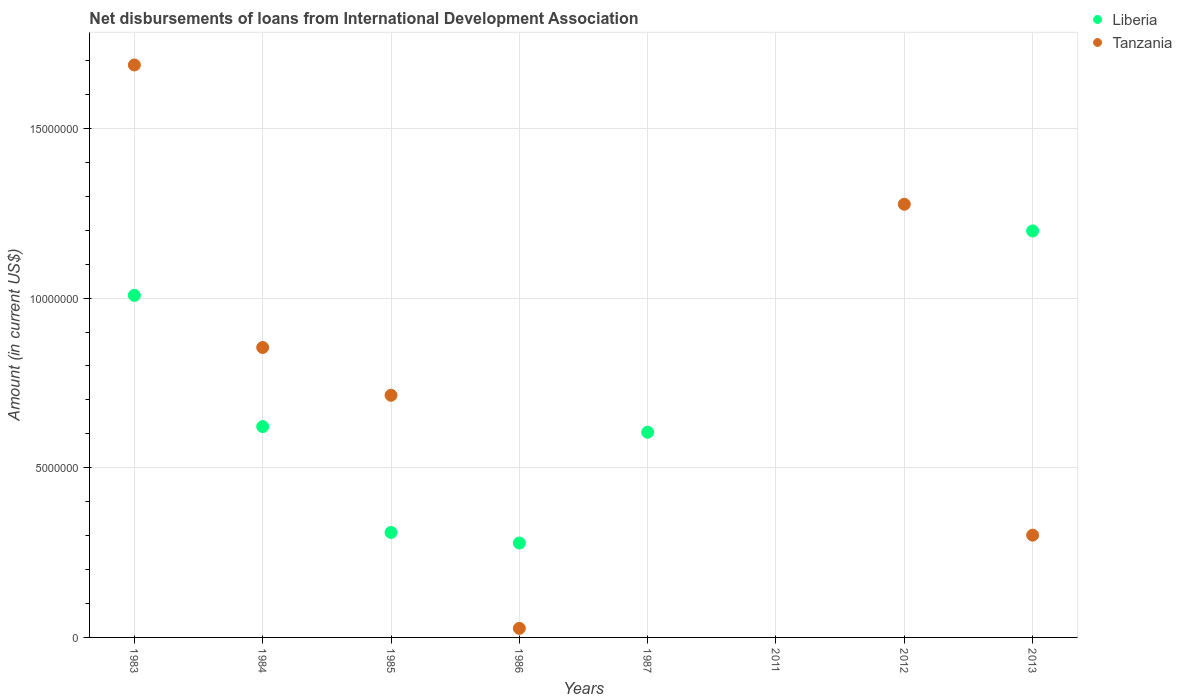How many different coloured dotlines are there?
Offer a very short reply. 2. Is the number of dotlines equal to the number of legend labels?
Make the answer very short. No. What is the amount of loans disbursed in Liberia in 1986?
Provide a succinct answer. 2.78e+06. Across all years, what is the maximum amount of loans disbursed in Liberia?
Provide a short and direct response. 1.20e+07. In which year was the amount of loans disbursed in Liberia maximum?
Make the answer very short. 2013. What is the total amount of loans disbursed in Tanzania in the graph?
Your answer should be compact. 4.86e+07. What is the difference between the amount of loans disbursed in Liberia in 1983 and that in 2013?
Provide a succinct answer. -1.90e+06. What is the difference between the amount of loans disbursed in Tanzania in 1984 and the amount of loans disbursed in Liberia in 2013?
Provide a short and direct response. -3.44e+06. What is the average amount of loans disbursed in Liberia per year?
Keep it short and to the point. 5.02e+06. In the year 1986, what is the difference between the amount of loans disbursed in Tanzania and amount of loans disbursed in Liberia?
Provide a short and direct response. -2.52e+06. What is the ratio of the amount of loans disbursed in Liberia in 1983 to that in 2013?
Provide a short and direct response. 0.84. Is the difference between the amount of loans disbursed in Tanzania in 1984 and 1986 greater than the difference between the amount of loans disbursed in Liberia in 1984 and 1986?
Offer a very short reply. Yes. What is the difference between the highest and the second highest amount of loans disbursed in Tanzania?
Provide a succinct answer. 4.10e+06. What is the difference between the highest and the lowest amount of loans disbursed in Tanzania?
Provide a short and direct response. 1.69e+07. In how many years, is the amount of loans disbursed in Liberia greater than the average amount of loans disbursed in Liberia taken over all years?
Provide a short and direct response. 4. Is the sum of the amount of loans disbursed in Tanzania in 1984 and 2013 greater than the maximum amount of loans disbursed in Liberia across all years?
Give a very brief answer. No. Does the amount of loans disbursed in Tanzania monotonically increase over the years?
Offer a very short reply. No. Is the amount of loans disbursed in Liberia strictly greater than the amount of loans disbursed in Tanzania over the years?
Give a very brief answer. No. How many dotlines are there?
Your answer should be very brief. 2. What is the difference between two consecutive major ticks on the Y-axis?
Ensure brevity in your answer.  5.00e+06. Are the values on the major ticks of Y-axis written in scientific E-notation?
Keep it short and to the point. No. Does the graph contain grids?
Give a very brief answer. Yes. Where does the legend appear in the graph?
Your answer should be very brief. Top right. How many legend labels are there?
Give a very brief answer. 2. What is the title of the graph?
Your response must be concise. Net disbursements of loans from International Development Association. Does "Malaysia" appear as one of the legend labels in the graph?
Keep it short and to the point. No. What is the label or title of the X-axis?
Give a very brief answer. Years. What is the Amount (in current US$) in Liberia in 1983?
Make the answer very short. 1.01e+07. What is the Amount (in current US$) in Tanzania in 1983?
Provide a short and direct response. 1.69e+07. What is the Amount (in current US$) in Liberia in 1984?
Offer a terse response. 6.21e+06. What is the Amount (in current US$) in Tanzania in 1984?
Ensure brevity in your answer.  8.54e+06. What is the Amount (in current US$) of Liberia in 1985?
Give a very brief answer. 3.09e+06. What is the Amount (in current US$) in Tanzania in 1985?
Give a very brief answer. 7.14e+06. What is the Amount (in current US$) of Liberia in 1986?
Provide a short and direct response. 2.78e+06. What is the Amount (in current US$) in Tanzania in 1986?
Provide a succinct answer. 2.67e+05. What is the Amount (in current US$) of Liberia in 1987?
Your answer should be compact. 6.05e+06. What is the Amount (in current US$) in Tanzania in 2011?
Provide a succinct answer. 0. What is the Amount (in current US$) of Liberia in 2012?
Your answer should be very brief. 0. What is the Amount (in current US$) in Tanzania in 2012?
Your answer should be very brief. 1.28e+07. What is the Amount (in current US$) in Liberia in 2013?
Offer a terse response. 1.20e+07. What is the Amount (in current US$) of Tanzania in 2013?
Provide a short and direct response. 3.01e+06. Across all years, what is the maximum Amount (in current US$) in Liberia?
Provide a succinct answer. 1.20e+07. Across all years, what is the maximum Amount (in current US$) of Tanzania?
Your answer should be very brief. 1.69e+07. Across all years, what is the minimum Amount (in current US$) of Tanzania?
Offer a terse response. 0. What is the total Amount (in current US$) of Liberia in the graph?
Offer a terse response. 4.02e+07. What is the total Amount (in current US$) in Tanzania in the graph?
Your answer should be very brief. 4.86e+07. What is the difference between the Amount (in current US$) of Liberia in 1983 and that in 1984?
Your answer should be compact. 3.87e+06. What is the difference between the Amount (in current US$) of Tanzania in 1983 and that in 1984?
Ensure brevity in your answer.  8.32e+06. What is the difference between the Amount (in current US$) of Liberia in 1983 and that in 1985?
Your response must be concise. 6.99e+06. What is the difference between the Amount (in current US$) in Tanzania in 1983 and that in 1985?
Offer a very short reply. 9.73e+06. What is the difference between the Amount (in current US$) in Liberia in 1983 and that in 1986?
Your answer should be compact. 7.30e+06. What is the difference between the Amount (in current US$) in Tanzania in 1983 and that in 1986?
Offer a very short reply. 1.66e+07. What is the difference between the Amount (in current US$) of Liberia in 1983 and that in 1987?
Offer a terse response. 4.03e+06. What is the difference between the Amount (in current US$) of Tanzania in 1983 and that in 2012?
Your answer should be compact. 4.10e+06. What is the difference between the Amount (in current US$) of Liberia in 1983 and that in 2013?
Provide a succinct answer. -1.90e+06. What is the difference between the Amount (in current US$) of Tanzania in 1983 and that in 2013?
Offer a very short reply. 1.39e+07. What is the difference between the Amount (in current US$) in Liberia in 1984 and that in 1985?
Provide a succinct answer. 3.12e+06. What is the difference between the Amount (in current US$) in Tanzania in 1984 and that in 1985?
Offer a terse response. 1.41e+06. What is the difference between the Amount (in current US$) in Liberia in 1984 and that in 1986?
Your answer should be compact. 3.43e+06. What is the difference between the Amount (in current US$) in Tanzania in 1984 and that in 1986?
Offer a terse response. 8.28e+06. What is the difference between the Amount (in current US$) in Liberia in 1984 and that in 1987?
Make the answer very short. 1.66e+05. What is the difference between the Amount (in current US$) in Tanzania in 1984 and that in 2012?
Your response must be concise. -4.22e+06. What is the difference between the Amount (in current US$) of Liberia in 1984 and that in 2013?
Ensure brevity in your answer.  -5.77e+06. What is the difference between the Amount (in current US$) in Tanzania in 1984 and that in 2013?
Your response must be concise. 5.53e+06. What is the difference between the Amount (in current US$) in Liberia in 1985 and that in 1986?
Offer a very short reply. 3.11e+05. What is the difference between the Amount (in current US$) in Tanzania in 1985 and that in 1986?
Give a very brief answer. 6.87e+06. What is the difference between the Amount (in current US$) of Liberia in 1985 and that in 1987?
Provide a short and direct response. -2.95e+06. What is the difference between the Amount (in current US$) of Tanzania in 1985 and that in 2012?
Make the answer very short. -5.63e+06. What is the difference between the Amount (in current US$) of Liberia in 1985 and that in 2013?
Your response must be concise. -8.89e+06. What is the difference between the Amount (in current US$) of Tanzania in 1985 and that in 2013?
Your answer should be compact. 4.12e+06. What is the difference between the Amount (in current US$) in Liberia in 1986 and that in 1987?
Provide a short and direct response. -3.26e+06. What is the difference between the Amount (in current US$) in Tanzania in 1986 and that in 2012?
Your answer should be very brief. -1.25e+07. What is the difference between the Amount (in current US$) of Liberia in 1986 and that in 2013?
Keep it short and to the point. -9.20e+06. What is the difference between the Amount (in current US$) of Tanzania in 1986 and that in 2013?
Keep it short and to the point. -2.75e+06. What is the difference between the Amount (in current US$) of Liberia in 1987 and that in 2013?
Provide a succinct answer. -5.93e+06. What is the difference between the Amount (in current US$) in Tanzania in 2012 and that in 2013?
Offer a very short reply. 9.75e+06. What is the difference between the Amount (in current US$) of Liberia in 1983 and the Amount (in current US$) of Tanzania in 1984?
Offer a terse response. 1.54e+06. What is the difference between the Amount (in current US$) of Liberia in 1983 and the Amount (in current US$) of Tanzania in 1985?
Provide a short and direct response. 2.94e+06. What is the difference between the Amount (in current US$) of Liberia in 1983 and the Amount (in current US$) of Tanzania in 1986?
Your answer should be compact. 9.81e+06. What is the difference between the Amount (in current US$) of Liberia in 1983 and the Amount (in current US$) of Tanzania in 2012?
Your response must be concise. -2.68e+06. What is the difference between the Amount (in current US$) in Liberia in 1983 and the Amount (in current US$) in Tanzania in 2013?
Offer a terse response. 7.07e+06. What is the difference between the Amount (in current US$) of Liberia in 1984 and the Amount (in current US$) of Tanzania in 1985?
Your response must be concise. -9.23e+05. What is the difference between the Amount (in current US$) in Liberia in 1984 and the Amount (in current US$) in Tanzania in 1986?
Give a very brief answer. 5.95e+06. What is the difference between the Amount (in current US$) of Liberia in 1984 and the Amount (in current US$) of Tanzania in 2012?
Your answer should be very brief. -6.55e+06. What is the difference between the Amount (in current US$) of Liberia in 1984 and the Amount (in current US$) of Tanzania in 2013?
Give a very brief answer. 3.20e+06. What is the difference between the Amount (in current US$) in Liberia in 1985 and the Amount (in current US$) in Tanzania in 1986?
Offer a very short reply. 2.83e+06. What is the difference between the Amount (in current US$) in Liberia in 1985 and the Amount (in current US$) in Tanzania in 2012?
Provide a succinct answer. -9.67e+06. What is the difference between the Amount (in current US$) of Liberia in 1985 and the Amount (in current US$) of Tanzania in 2013?
Give a very brief answer. 7.90e+04. What is the difference between the Amount (in current US$) of Liberia in 1986 and the Amount (in current US$) of Tanzania in 2012?
Ensure brevity in your answer.  -9.98e+06. What is the difference between the Amount (in current US$) in Liberia in 1986 and the Amount (in current US$) in Tanzania in 2013?
Your response must be concise. -2.32e+05. What is the difference between the Amount (in current US$) of Liberia in 1987 and the Amount (in current US$) of Tanzania in 2012?
Provide a short and direct response. -6.72e+06. What is the difference between the Amount (in current US$) of Liberia in 1987 and the Amount (in current US$) of Tanzania in 2013?
Provide a short and direct response. 3.03e+06. What is the average Amount (in current US$) in Liberia per year?
Make the answer very short. 5.02e+06. What is the average Amount (in current US$) of Tanzania per year?
Make the answer very short. 6.07e+06. In the year 1983, what is the difference between the Amount (in current US$) in Liberia and Amount (in current US$) in Tanzania?
Your answer should be very brief. -6.79e+06. In the year 1984, what is the difference between the Amount (in current US$) in Liberia and Amount (in current US$) in Tanzania?
Make the answer very short. -2.33e+06. In the year 1985, what is the difference between the Amount (in current US$) in Liberia and Amount (in current US$) in Tanzania?
Provide a succinct answer. -4.04e+06. In the year 1986, what is the difference between the Amount (in current US$) in Liberia and Amount (in current US$) in Tanzania?
Keep it short and to the point. 2.52e+06. In the year 2013, what is the difference between the Amount (in current US$) in Liberia and Amount (in current US$) in Tanzania?
Make the answer very short. 8.96e+06. What is the ratio of the Amount (in current US$) in Liberia in 1983 to that in 1984?
Provide a short and direct response. 1.62. What is the ratio of the Amount (in current US$) of Tanzania in 1983 to that in 1984?
Your response must be concise. 1.97. What is the ratio of the Amount (in current US$) in Liberia in 1983 to that in 1985?
Ensure brevity in your answer.  3.26. What is the ratio of the Amount (in current US$) in Tanzania in 1983 to that in 1985?
Make the answer very short. 2.36. What is the ratio of the Amount (in current US$) in Liberia in 1983 to that in 1986?
Your response must be concise. 3.62. What is the ratio of the Amount (in current US$) of Tanzania in 1983 to that in 1986?
Offer a very short reply. 63.18. What is the ratio of the Amount (in current US$) of Liberia in 1983 to that in 1987?
Provide a succinct answer. 1.67. What is the ratio of the Amount (in current US$) of Tanzania in 1983 to that in 2012?
Offer a terse response. 1.32. What is the ratio of the Amount (in current US$) in Liberia in 1983 to that in 2013?
Your response must be concise. 0.84. What is the ratio of the Amount (in current US$) in Tanzania in 1983 to that in 2013?
Offer a very short reply. 5.6. What is the ratio of the Amount (in current US$) of Liberia in 1984 to that in 1985?
Offer a very short reply. 2.01. What is the ratio of the Amount (in current US$) of Tanzania in 1984 to that in 1985?
Ensure brevity in your answer.  1.2. What is the ratio of the Amount (in current US$) in Liberia in 1984 to that in 1986?
Make the answer very short. 2.23. What is the ratio of the Amount (in current US$) in Tanzania in 1984 to that in 1986?
Give a very brief answer. 32. What is the ratio of the Amount (in current US$) of Liberia in 1984 to that in 1987?
Provide a short and direct response. 1.03. What is the ratio of the Amount (in current US$) of Tanzania in 1984 to that in 2012?
Your response must be concise. 0.67. What is the ratio of the Amount (in current US$) of Liberia in 1984 to that in 2013?
Make the answer very short. 0.52. What is the ratio of the Amount (in current US$) in Tanzania in 1984 to that in 2013?
Your response must be concise. 2.83. What is the ratio of the Amount (in current US$) in Liberia in 1985 to that in 1986?
Give a very brief answer. 1.11. What is the ratio of the Amount (in current US$) in Tanzania in 1985 to that in 1986?
Ensure brevity in your answer.  26.73. What is the ratio of the Amount (in current US$) in Liberia in 1985 to that in 1987?
Your response must be concise. 0.51. What is the ratio of the Amount (in current US$) in Tanzania in 1985 to that in 2012?
Make the answer very short. 0.56. What is the ratio of the Amount (in current US$) in Liberia in 1985 to that in 2013?
Provide a succinct answer. 0.26. What is the ratio of the Amount (in current US$) in Tanzania in 1985 to that in 2013?
Provide a short and direct response. 2.37. What is the ratio of the Amount (in current US$) of Liberia in 1986 to that in 1987?
Your answer should be very brief. 0.46. What is the ratio of the Amount (in current US$) of Tanzania in 1986 to that in 2012?
Your response must be concise. 0.02. What is the ratio of the Amount (in current US$) of Liberia in 1986 to that in 2013?
Make the answer very short. 0.23. What is the ratio of the Amount (in current US$) of Tanzania in 1986 to that in 2013?
Make the answer very short. 0.09. What is the ratio of the Amount (in current US$) of Liberia in 1987 to that in 2013?
Make the answer very short. 0.5. What is the ratio of the Amount (in current US$) of Tanzania in 2012 to that in 2013?
Provide a succinct answer. 4.24. What is the difference between the highest and the second highest Amount (in current US$) in Liberia?
Offer a very short reply. 1.90e+06. What is the difference between the highest and the second highest Amount (in current US$) of Tanzania?
Make the answer very short. 4.10e+06. What is the difference between the highest and the lowest Amount (in current US$) of Liberia?
Keep it short and to the point. 1.20e+07. What is the difference between the highest and the lowest Amount (in current US$) in Tanzania?
Offer a terse response. 1.69e+07. 